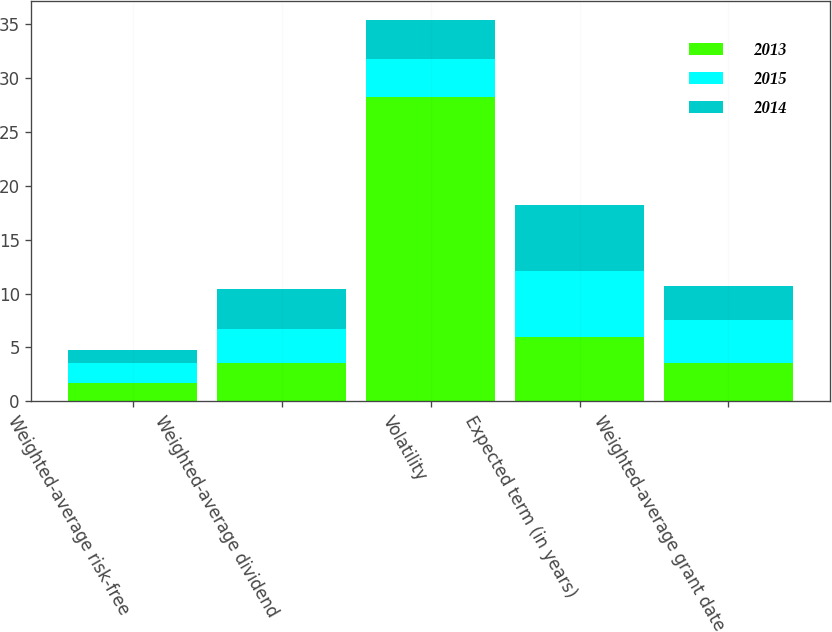<chart> <loc_0><loc_0><loc_500><loc_500><stacked_bar_chart><ecel><fcel>Weighted-average risk-free<fcel>Weighted-average dividend<fcel>Volatility<fcel>Expected term (in years)<fcel>Weighted-average grant date<nl><fcel>2013<fcel>1.7<fcel>3.6<fcel>28.2<fcel>6<fcel>3.58<nl><fcel>2015<fcel>1.9<fcel>3.1<fcel>3.6<fcel>6.09<fcel>3.95<nl><fcel>2014<fcel>1.2<fcel>3.7<fcel>3.6<fcel>6.09<fcel>3.2<nl></chart> 